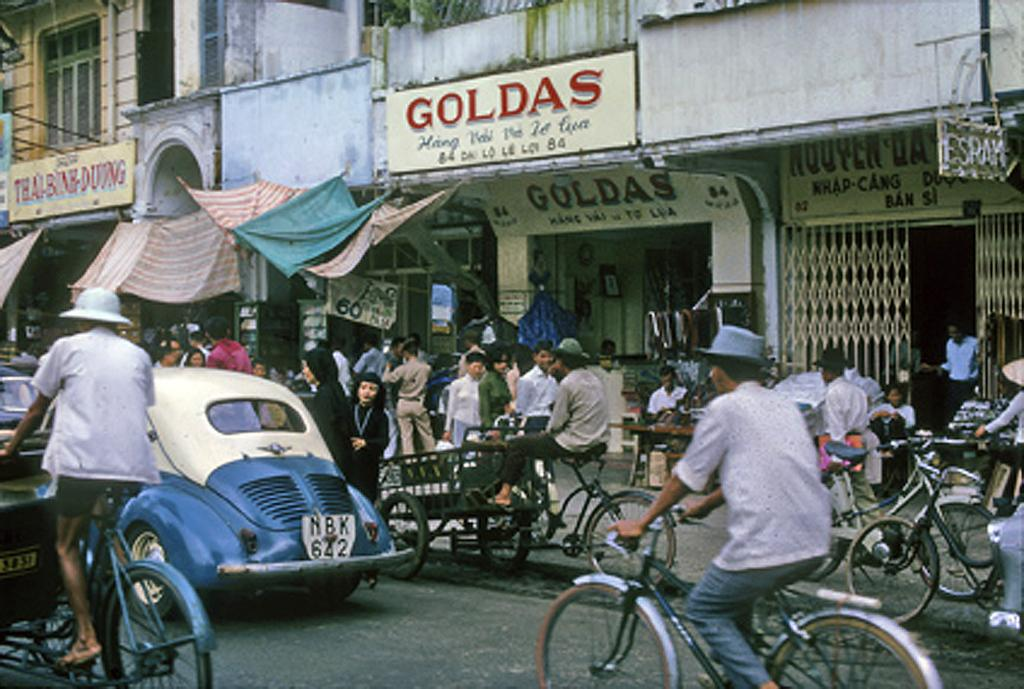What are the people in the image doing? There is a group of people in the image, and some are riding bicycles on the road while others are walking on a pathway. What can be seen in the background of the image? There are buildings visible in the image. Are there any advertisements or signs in the image? Yes, there are hoardings present in the image. What songs are the people singing while walking in the image? There is no indication in the image that the people are singing songs, so it cannot be determined from the picture. 